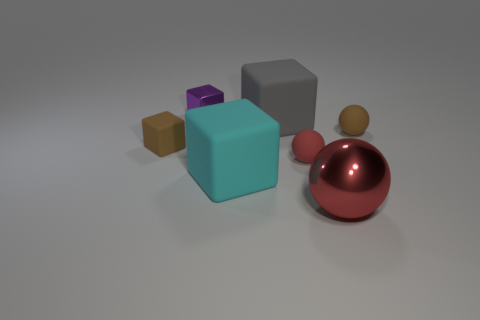What is the purpose of the large teal cube in the composition? The large teal cube in the image serves as a central focal point, possibly representing stability or balance in this group of objects. Its bold color and size draw attention, making it a dominant element in the visual composition. How does the color of the cube affect its perception? The vibrant teal color of the cube can evoke feelings of calmness and creativity. This choice of color might be intended to make the cube stand out among the other objects, influencing the viewer's perception by highlighting it as an element of interest in the composition. 